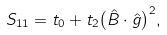Convert formula to latex. <formula><loc_0><loc_0><loc_500><loc_500>S _ { 1 1 } = t _ { 0 } + t _ { 2 } { \left ( \hat { B } \cdot \hat { g } \right ) } ^ { 2 } ,</formula> 